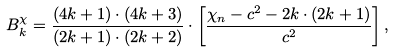<formula> <loc_0><loc_0><loc_500><loc_500>B ^ { \chi } _ { k } = \frac { ( 4 k + 1 ) \cdot ( 4 k + 3 ) } { ( 2 k + 1 ) \cdot ( 2 k + 2 ) } \cdot \left [ \frac { \chi _ { n } - c ^ { 2 } - 2 k \cdot ( 2 k + 1 ) } { c ^ { 2 } } \right ] ,</formula> 